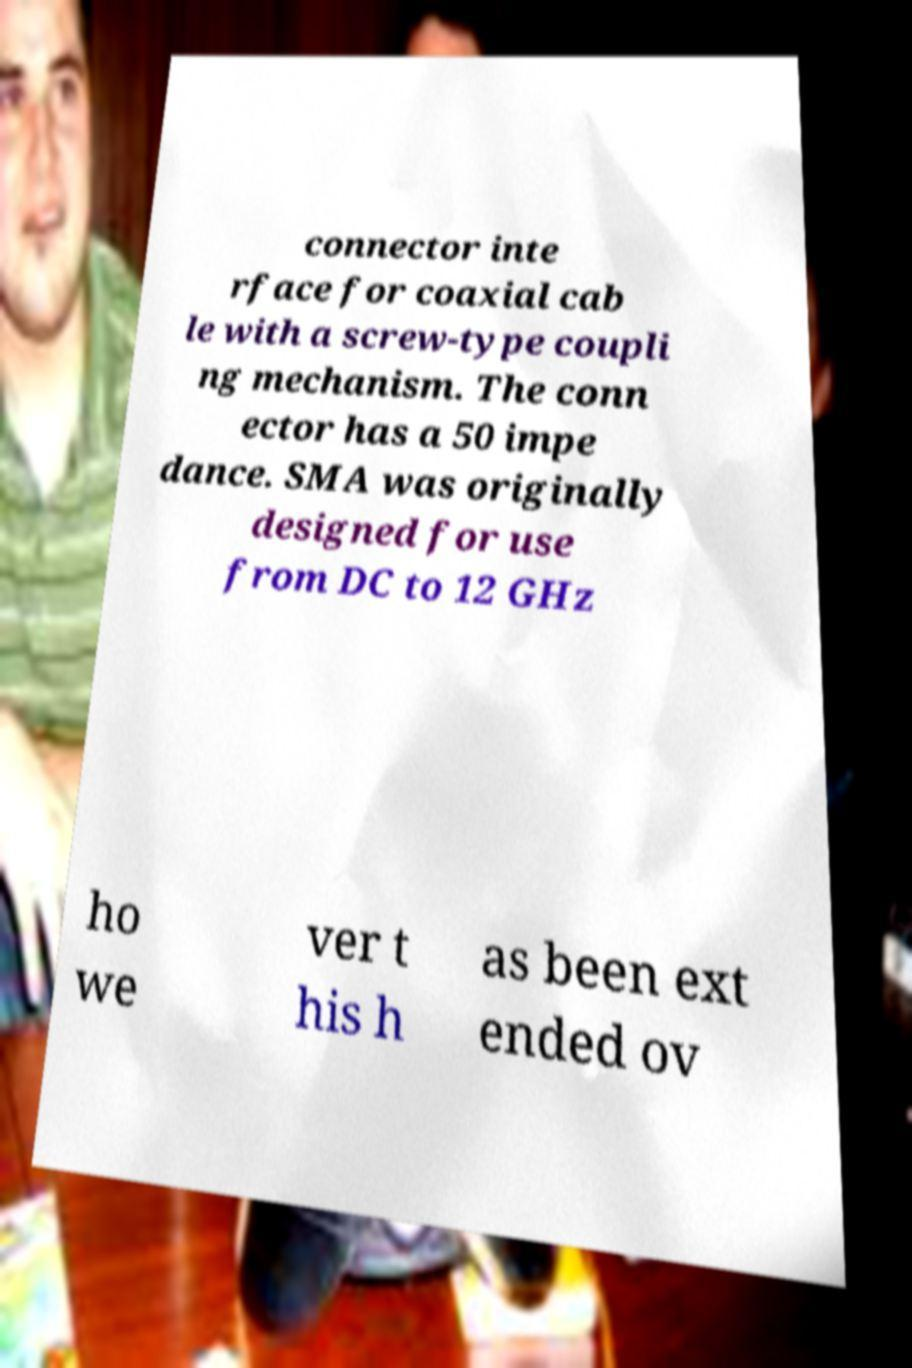Can you accurately transcribe the text from the provided image for me? connector inte rface for coaxial cab le with a screw-type coupli ng mechanism. The conn ector has a 50 impe dance. SMA was originally designed for use from DC to 12 GHz ho we ver t his h as been ext ended ov 